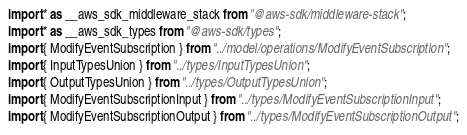<code> <loc_0><loc_0><loc_500><loc_500><_TypeScript_>import * as __aws_sdk_middleware_stack from "@aws-sdk/middleware-stack";
import * as __aws_sdk_types from "@aws-sdk/types";
import { ModifyEventSubscription } from "../model/operations/ModifyEventSubscription";
import { InputTypesUnion } from "../types/InputTypesUnion";
import { OutputTypesUnion } from "../types/OutputTypesUnion";
import { ModifyEventSubscriptionInput } from "../types/ModifyEventSubscriptionInput";
import { ModifyEventSubscriptionOutput } from "../types/ModifyEventSubscriptionOutput";</code> 